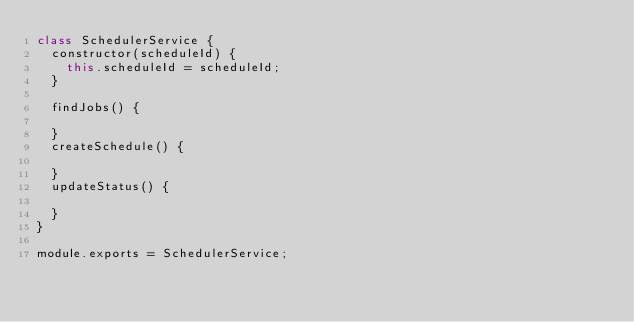<code> <loc_0><loc_0><loc_500><loc_500><_JavaScript_>class SchedulerService {
  constructor(scheduleId) {
    this.scheduleId = scheduleId;
  }

  findJobs() {

  }
  createSchedule() {

  }
  updateStatus() {

  }
}

module.exports = SchedulerService;</code> 